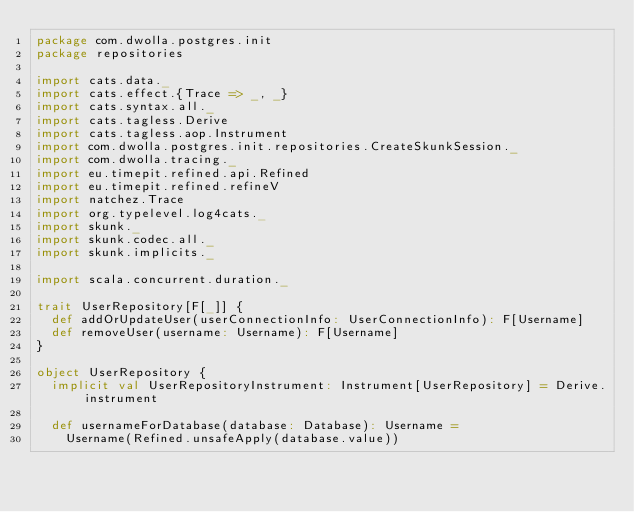Convert code to text. <code><loc_0><loc_0><loc_500><loc_500><_Scala_>package com.dwolla.postgres.init
package repositories

import cats.data._
import cats.effect.{Trace => _, _}
import cats.syntax.all._
import cats.tagless.Derive
import cats.tagless.aop.Instrument
import com.dwolla.postgres.init.repositories.CreateSkunkSession._
import com.dwolla.tracing._
import eu.timepit.refined.api.Refined
import eu.timepit.refined.refineV
import natchez.Trace
import org.typelevel.log4cats._
import skunk._
import skunk.codec.all._
import skunk.implicits._

import scala.concurrent.duration._

trait UserRepository[F[_]] {
  def addOrUpdateUser(userConnectionInfo: UserConnectionInfo): F[Username]
  def removeUser(username: Username): F[Username]
}

object UserRepository {
  implicit val UserRepositoryInstrument: Instrument[UserRepository] = Derive.instrument

  def usernameForDatabase(database: Database): Username =
    Username(Refined.unsafeApply(database.value))
</code> 